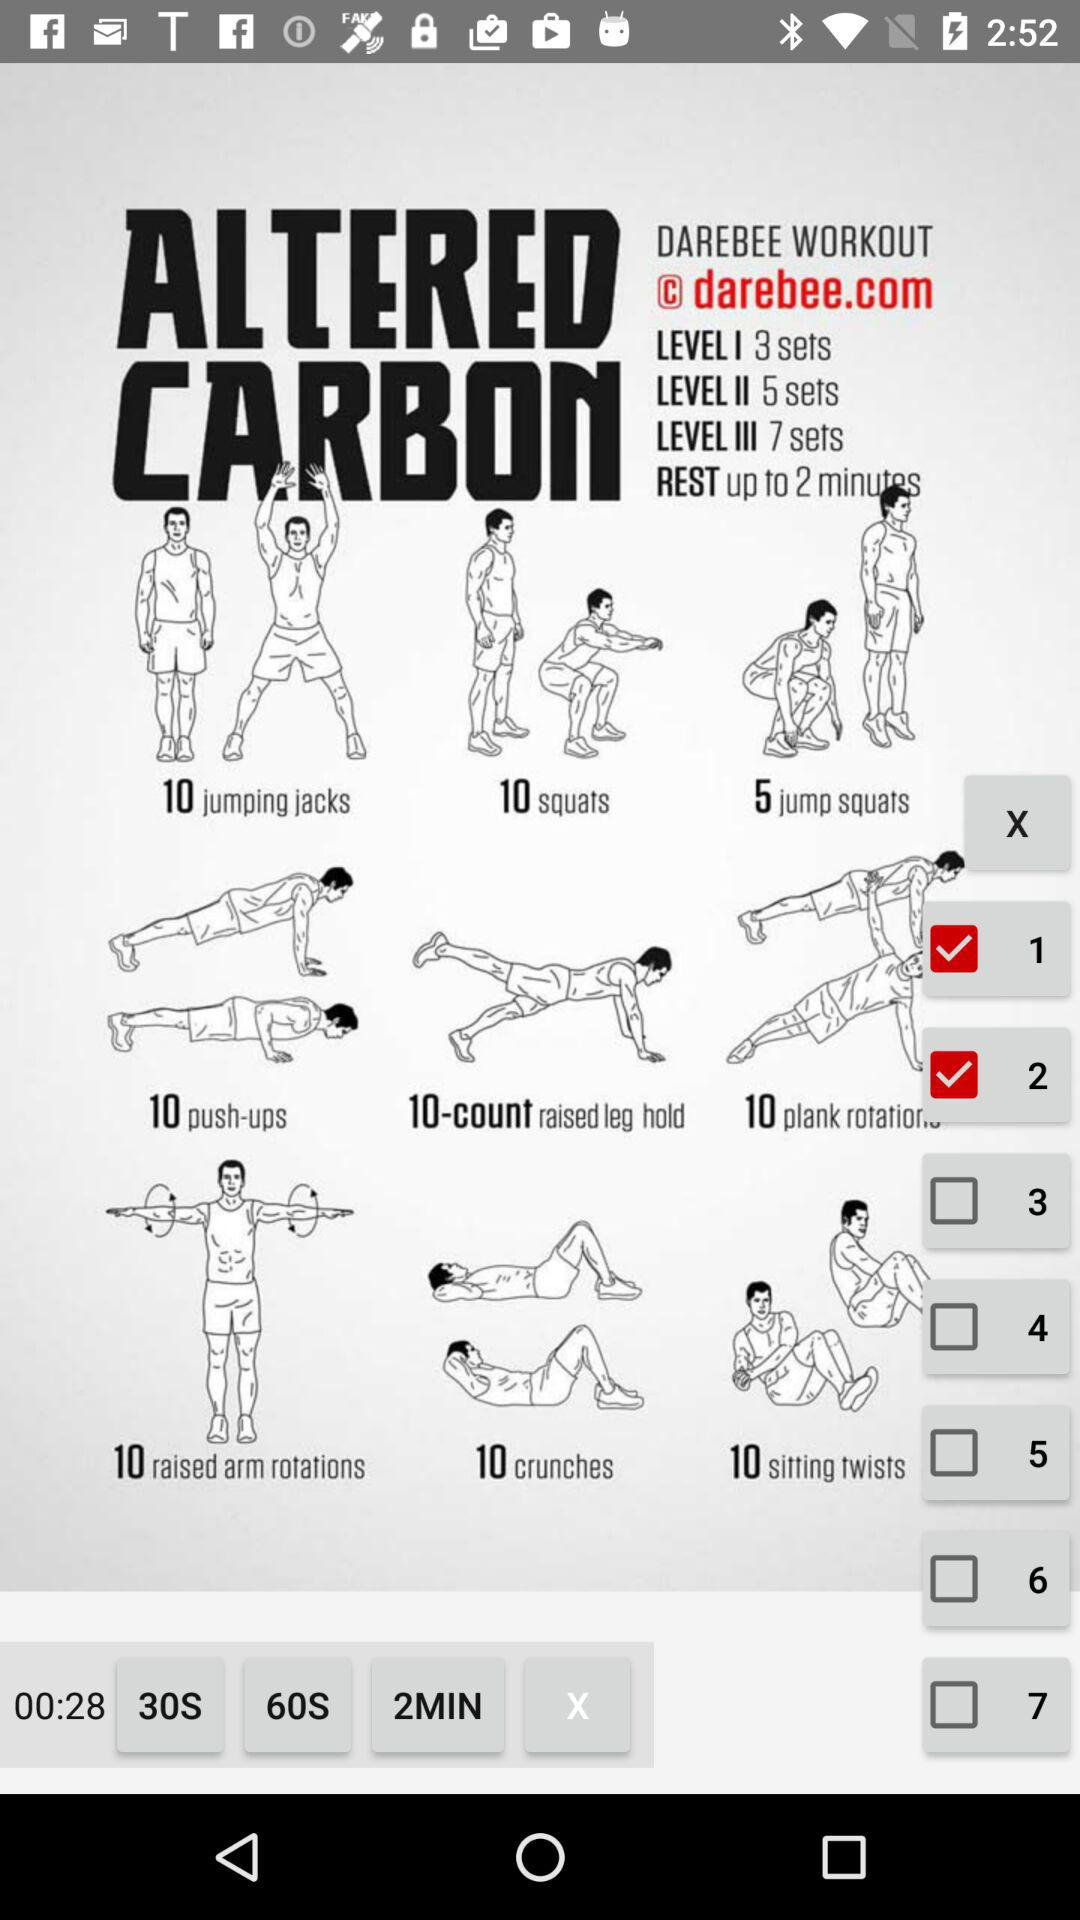How many sets of jump squats are there?
Answer the question using a single word or phrase. 5 